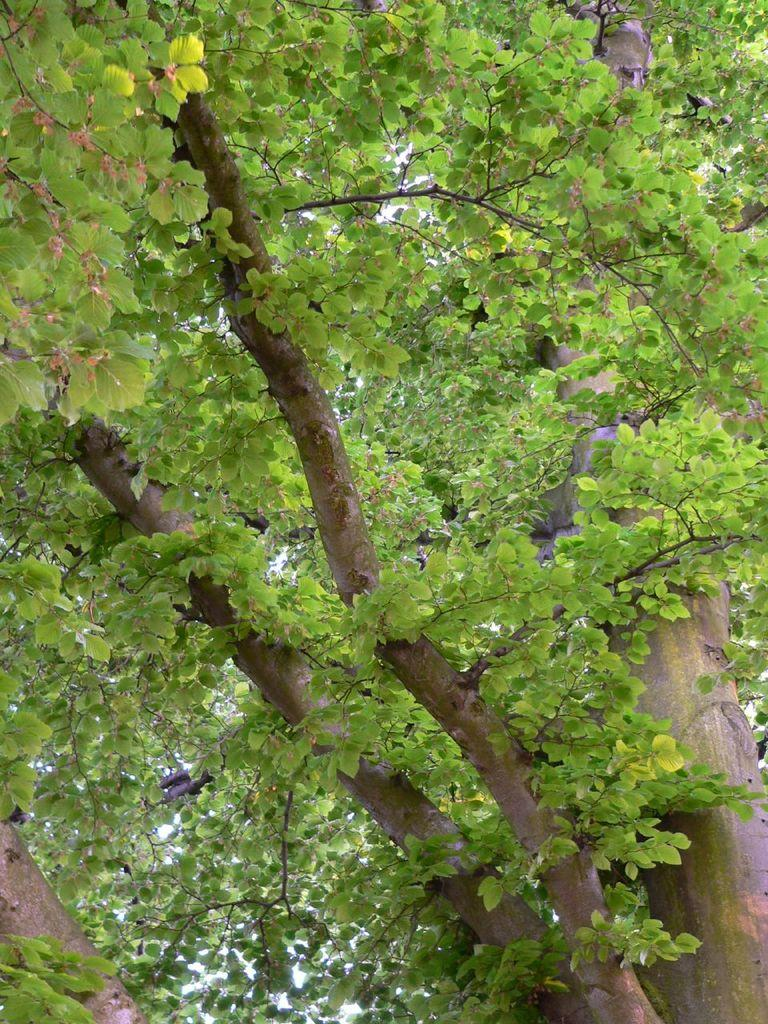What type of plant can be seen in the image? There is a tree in the image. What part of the natural environment is visible in the image? The sky is visible in the image. How many beds can be seen in the image? There are no beds present in the image. What type of work environment is depicted in the image? There is no office or work environment depicted in the image; it features a tree and the sky. 